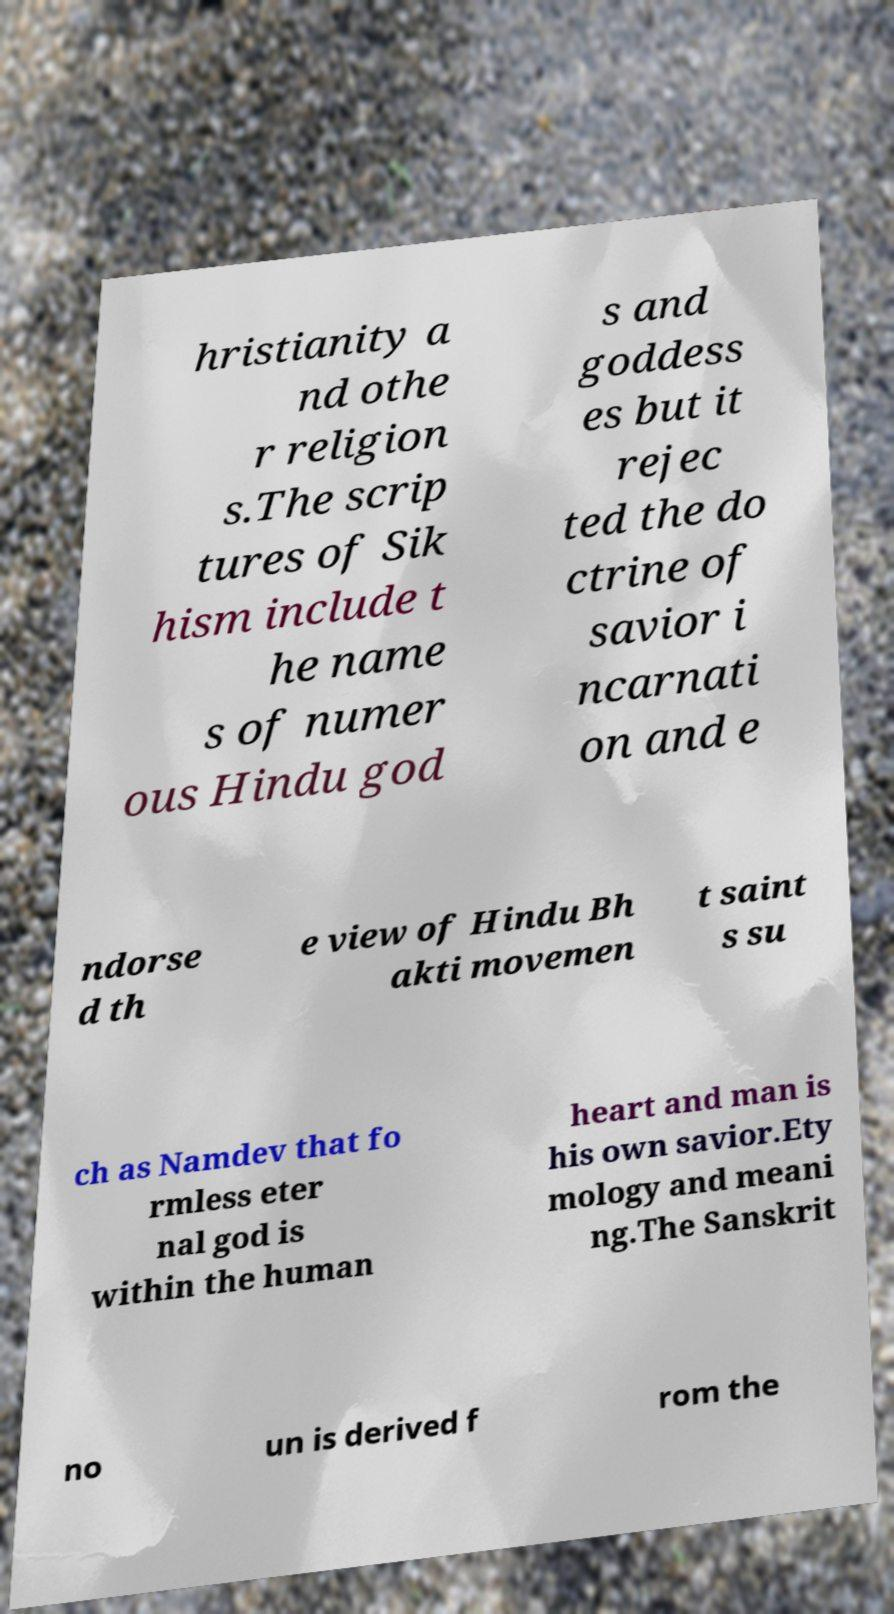Can you read and provide the text displayed in the image?This photo seems to have some interesting text. Can you extract and type it out for me? hristianity a nd othe r religion s.The scrip tures of Sik hism include t he name s of numer ous Hindu god s and goddess es but it rejec ted the do ctrine of savior i ncarnati on and e ndorse d th e view of Hindu Bh akti movemen t saint s su ch as Namdev that fo rmless eter nal god is within the human heart and man is his own savior.Ety mology and meani ng.The Sanskrit no un is derived f rom the 